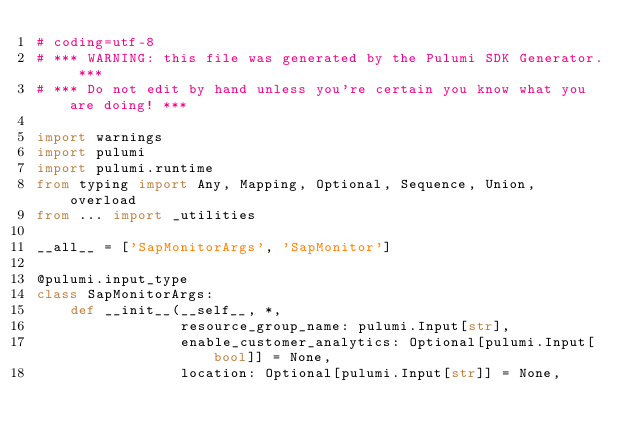<code> <loc_0><loc_0><loc_500><loc_500><_Python_># coding=utf-8
# *** WARNING: this file was generated by the Pulumi SDK Generator. ***
# *** Do not edit by hand unless you're certain you know what you are doing! ***

import warnings
import pulumi
import pulumi.runtime
from typing import Any, Mapping, Optional, Sequence, Union, overload
from ... import _utilities

__all__ = ['SapMonitorArgs', 'SapMonitor']

@pulumi.input_type
class SapMonitorArgs:
    def __init__(__self__, *,
                 resource_group_name: pulumi.Input[str],
                 enable_customer_analytics: Optional[pulumi.Input[bool]] = None,
                 location: Optional[pulumi.Input[str]] = None,</code> 